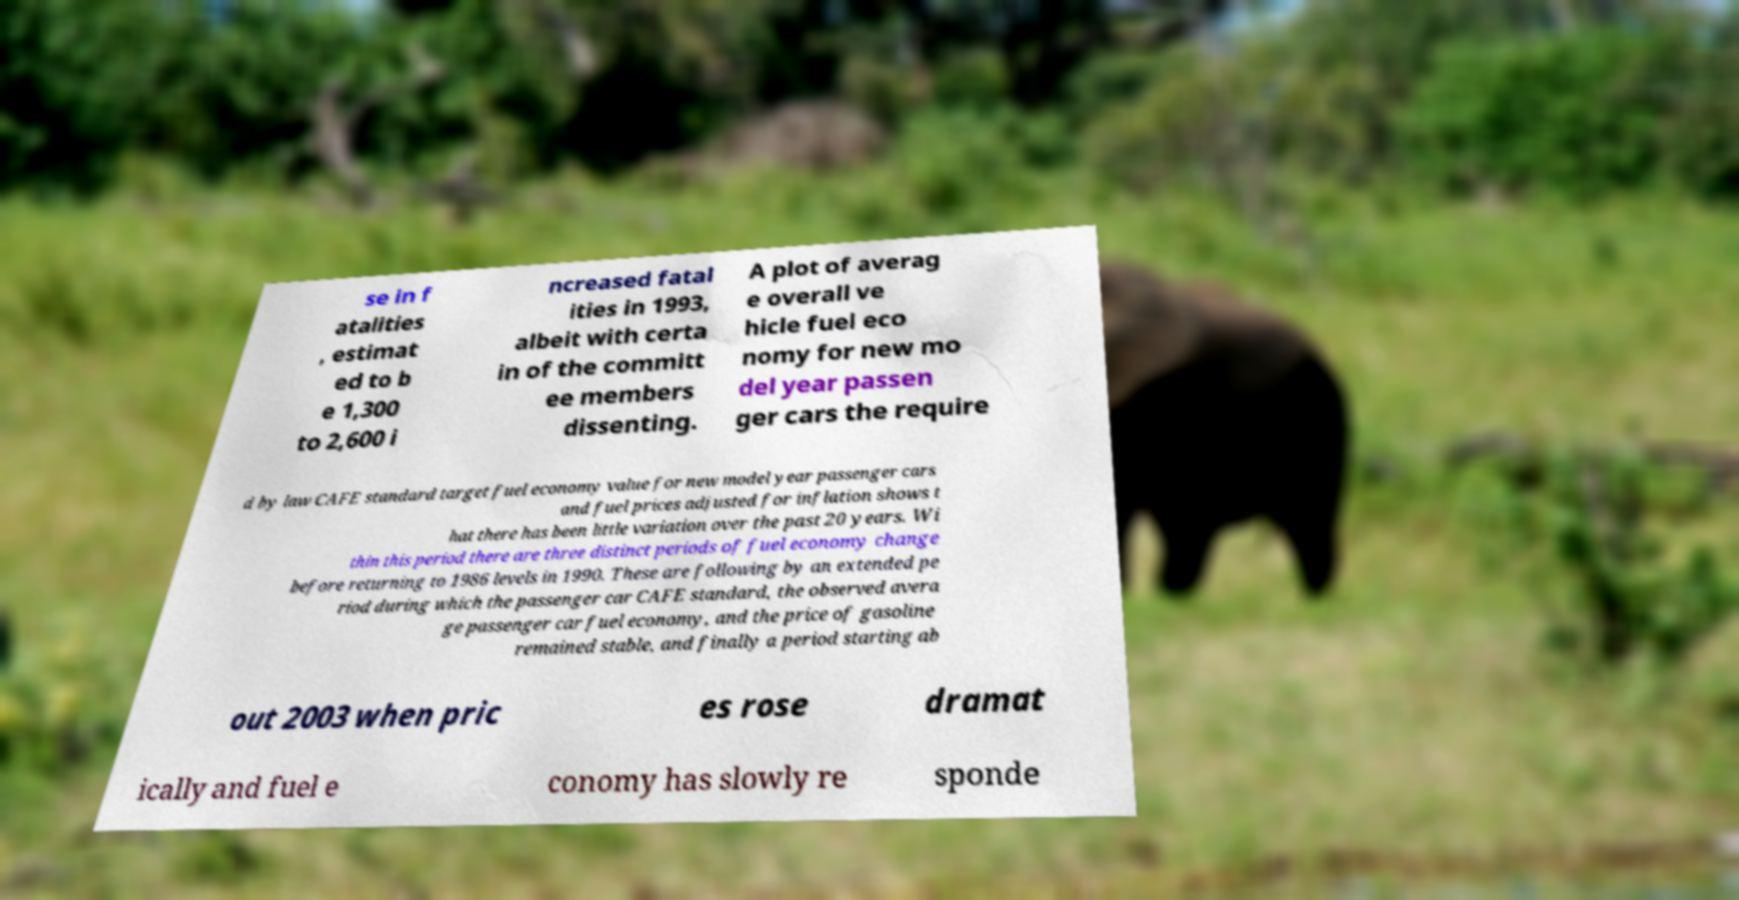Please identify and transcribe the text found in this image. se in f atalities , estimat ed to b e 1,300 to 2,600 i ncreased fatal ities in 1993, albeit with certa in of the committ ee members dissenting. A plot of averag e overall ve hicle fuel eco nomy for new mo del year passen ger cars the require d by law CAFE standard target fuel economy value for new model year passenger cars and fuel prices adjusted for inflation shows t hat there has been little variation over the past 20 years. Wi thin this period there are three distinct periods of fuel economy change before returning to 1986 levels in 1990. These are following by an extended pe riod during which the passenger car CAFE standard, the observed avera ge passenger car fuel economy, and the price of gasoline remained stable, and finally a period starting ab out 2003 when pric es rose dramat ically and fuel e conomy has slowly re sponde 